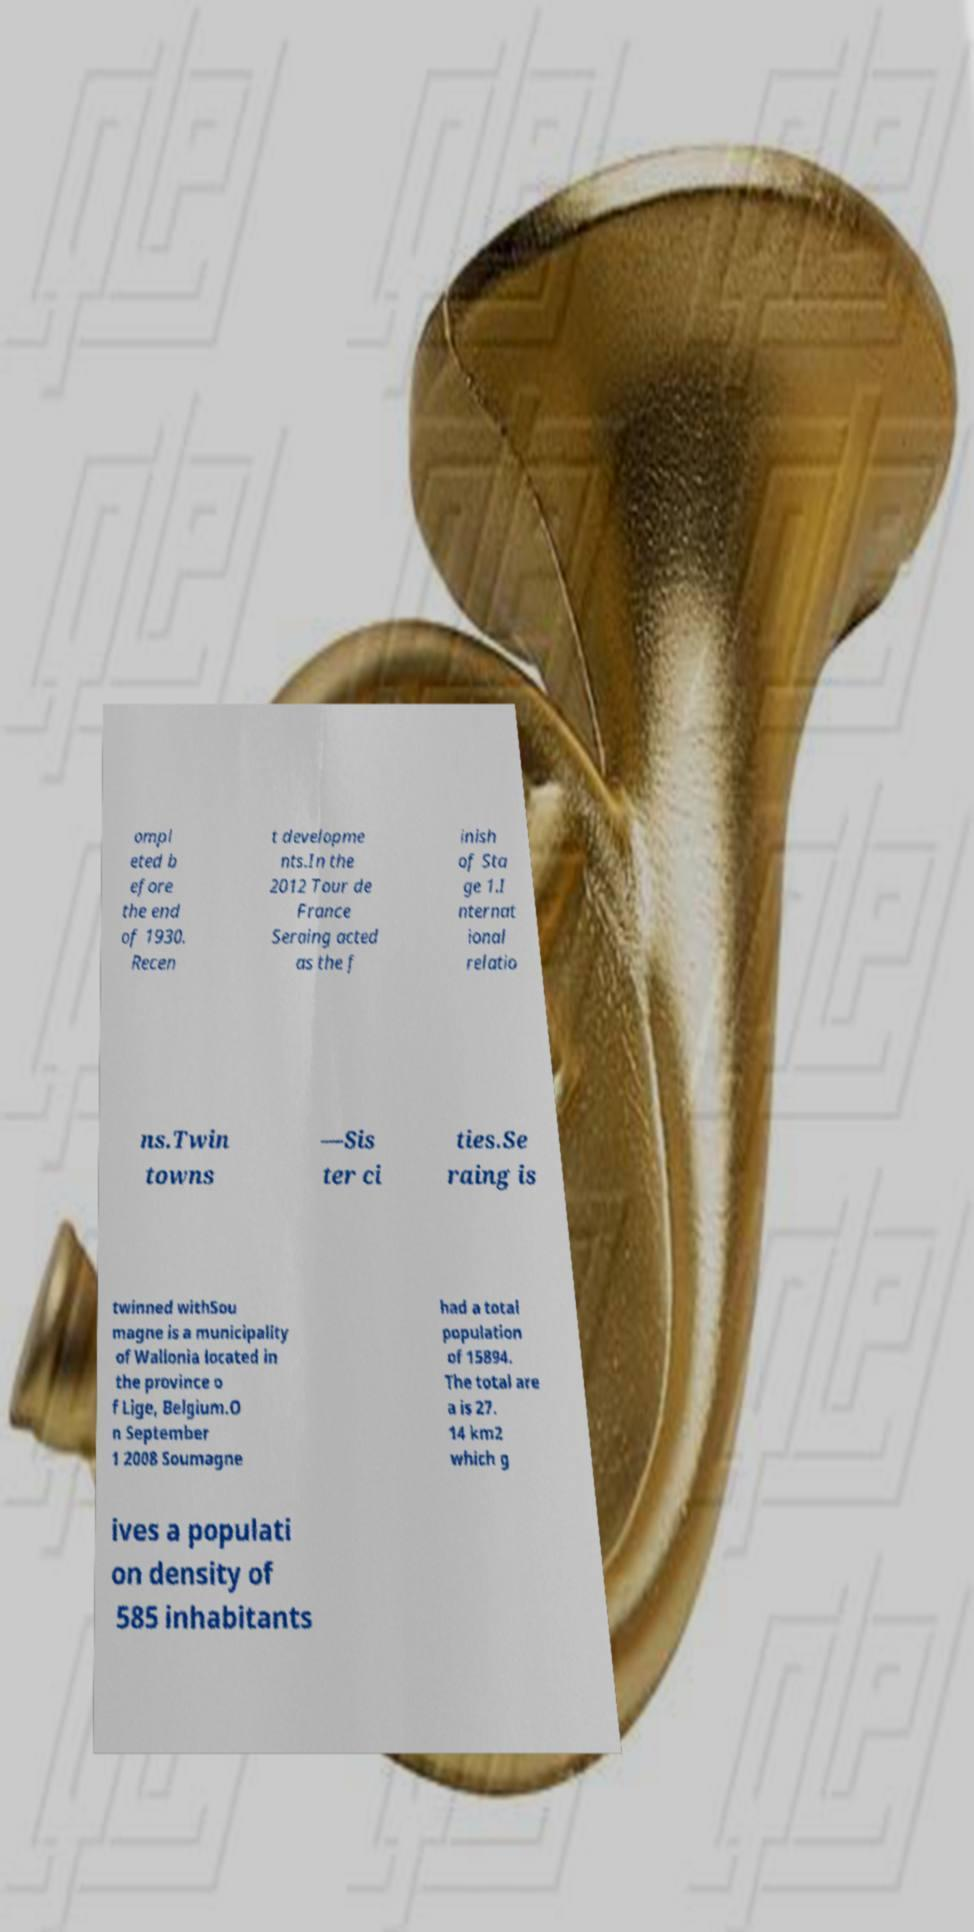Could you assist in decoding the text presented in this image and type it out clearly? ompl eted b efore the end of 1930. Recen t developme nts.In the 2012 Tour de France Seraing acted as the f inish of Sta ge 1.I nternat ional relatio ns.Twin towns —Sis ter ci ties.Se raing is twinned withSou magne is a municipality of Wallonia located in the province o f Lige, Belgium.O n September 1 2008 Soumagne had a total population of 15894. The total are a is 27. 14 km2 which g ives a populati on density of 585 inhabitants 